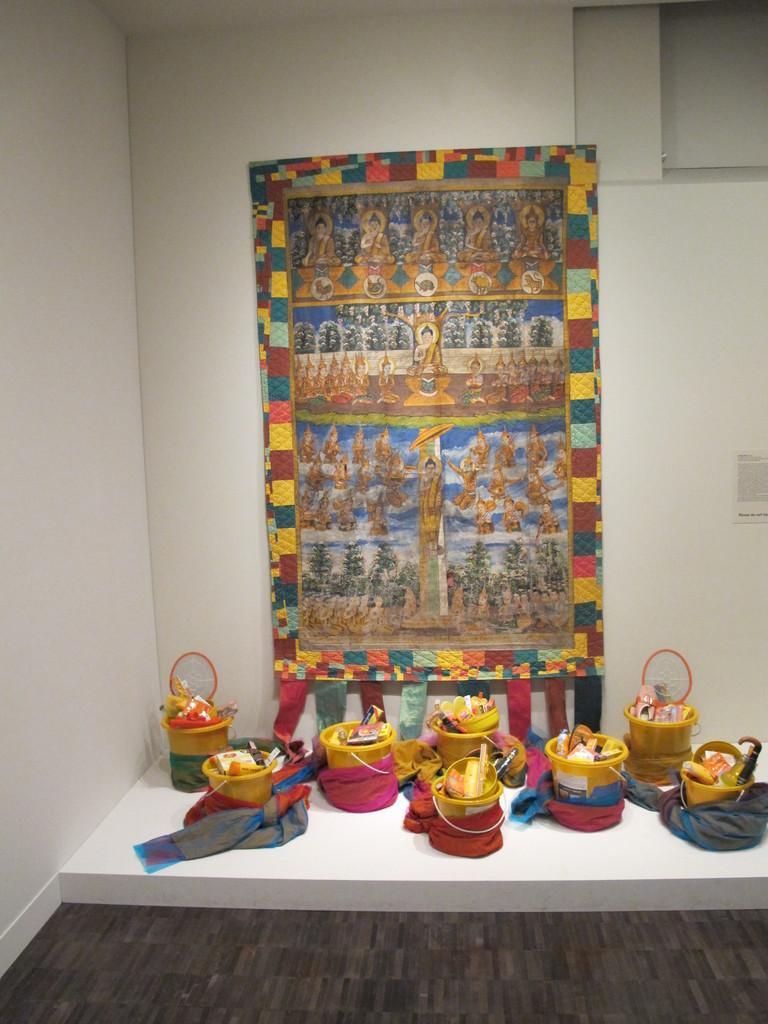Please provide a concise description of this image. As we can see in the image there is a wall, buckets and a frame. 